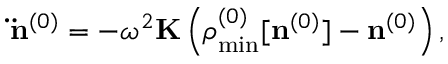<formula> <loc_0><loc_0><loc_500><loc_500>{ \ddot { n } } ^ { ( 0 ) } = - \omega ^ { 2 } { K } \left ( { \boldsymbol \rho } _ { \min } ^ { ( 0 ) } [ { n } ^ { ( 0 ) } ] - { n } ^ { ( 0 ) } \right ) ,</formula> 